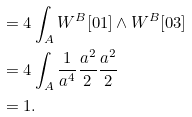<formula> <loc_0><loc_0><loc_500><loc_500>& = 4 \int _ { A } W ^ { B } [ 0 1 ] \wedge W ^ { B } [ 0 3 ] \\ & = 4 \int _ { A } \frac { 1 } { a ^ { 4 } } \frac { a ^ { 2 } } { 2 } \frac { a ^ { 2 } } { 2 } \\ & = 1 .</formula> 